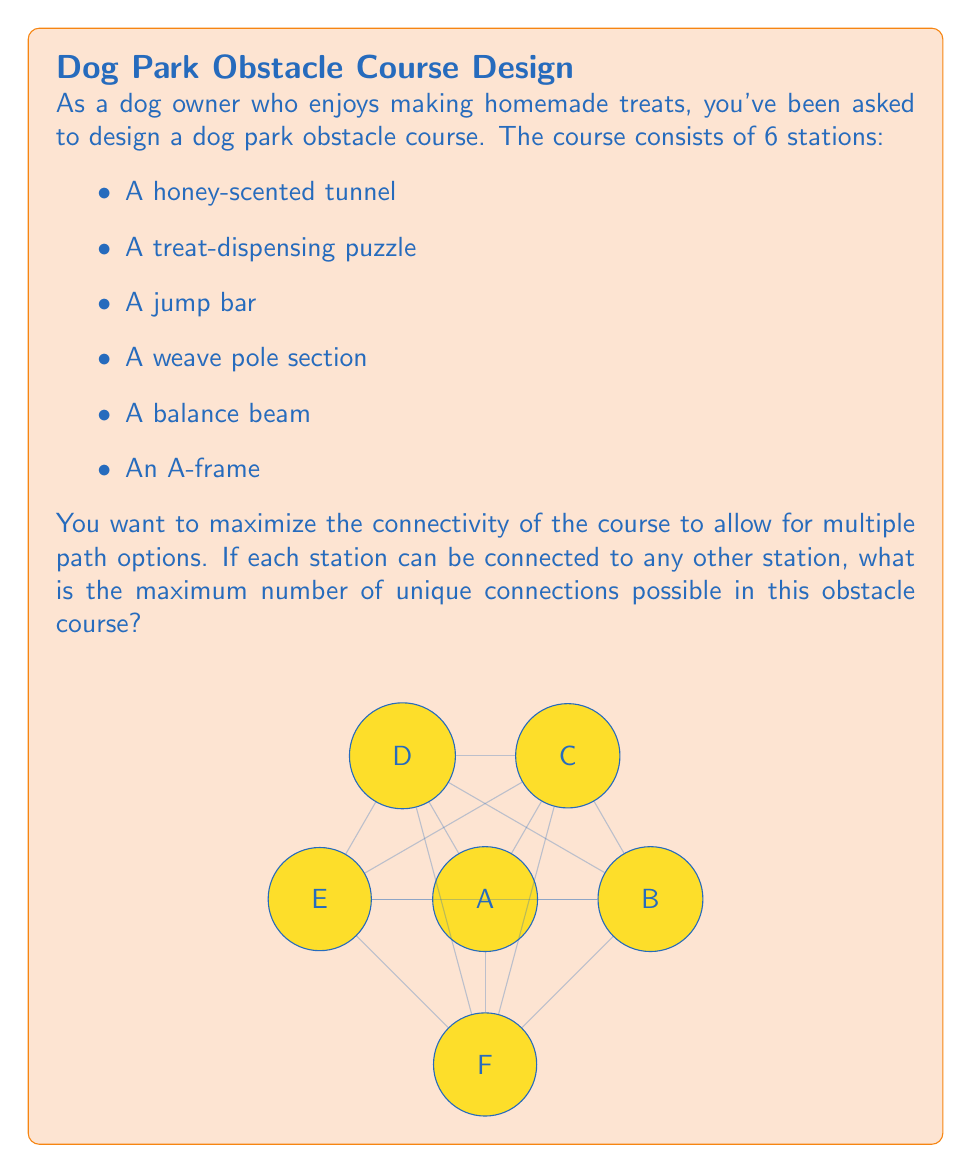Help me with this question. To solve this problem, we need to understand the concept of complete graphs in graph theory. In a complete graph, every vertex (station in our case) is connected to every other vertex.

Let's approach this step-by-step:

1) First, we need to calculate the number of edges in a complete graph with 6 vertices.

2) The formula for the number of edges in a complete graph with $n$ vertices is:

   $$E = \frac{n(n-1)}{2}$$

3) In our case, $n = 6$ (6 stations), so we plug this into the formula:

   $$E = \frac{6(6-1)}{2} = \frac{6 \times 5}{2} = \frac{30}{2} = 15$$

4) We can verify this result by counting the connections:
   - Station A connects to 5 other stations
   - Station B connects to 4 remaining stations
   - Station C connects to 3 remaining stations
   - Station D connects to 2 remaining stations
   - Station E connects to 1 remaining station
   - Station F has no remaining connections

5) Adding these up: 5 + 4 + 3 + 2 + 1 = 15

Therefore, the maximum number of unique connections in this obstacle course is 15.
Answer: 15 connections 